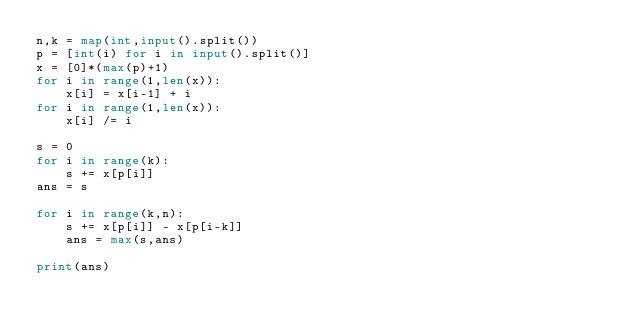Convert code to text. <code><loc_0><loc_0><loc_500><loc_500><_Python_>n,k = map(int,input().split())
p = [int(i) for i in input().split()]
x = [0]*(max(p)+1)
for i in range(1,len(x)):
    x[i] = x[i-1] + i
for i in range(1,len(x)):
    x[i] /= i

s = 0
for i in range(k):
    s += x[p[i]]
ans = s

for i in range(k,n):
    s += x[p[i]] - x[p[i-k]]
    ans = max(s,ans)

print(ans)</code> 